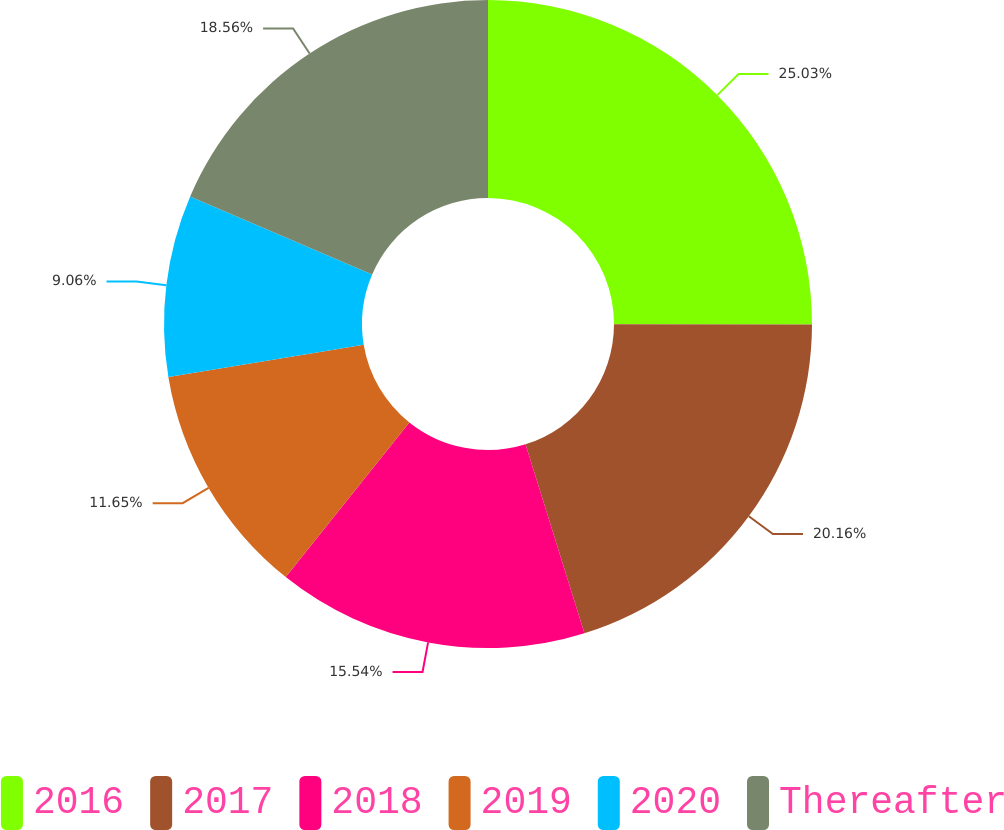Convert chart to OTSL. <chart><loc_0><loc_0><loc_500><loc_500><pie_chart><fcel>2016<fcel>2017<fcel>2018<fcel>2019<fcel>2020<fcel>Thereafter<nl><fcel>25.03%<fcel>20.16%<fcel>15.54%<fcel>11.65%<fcel>9.06%<fcel>18.56%<nl></chart> 